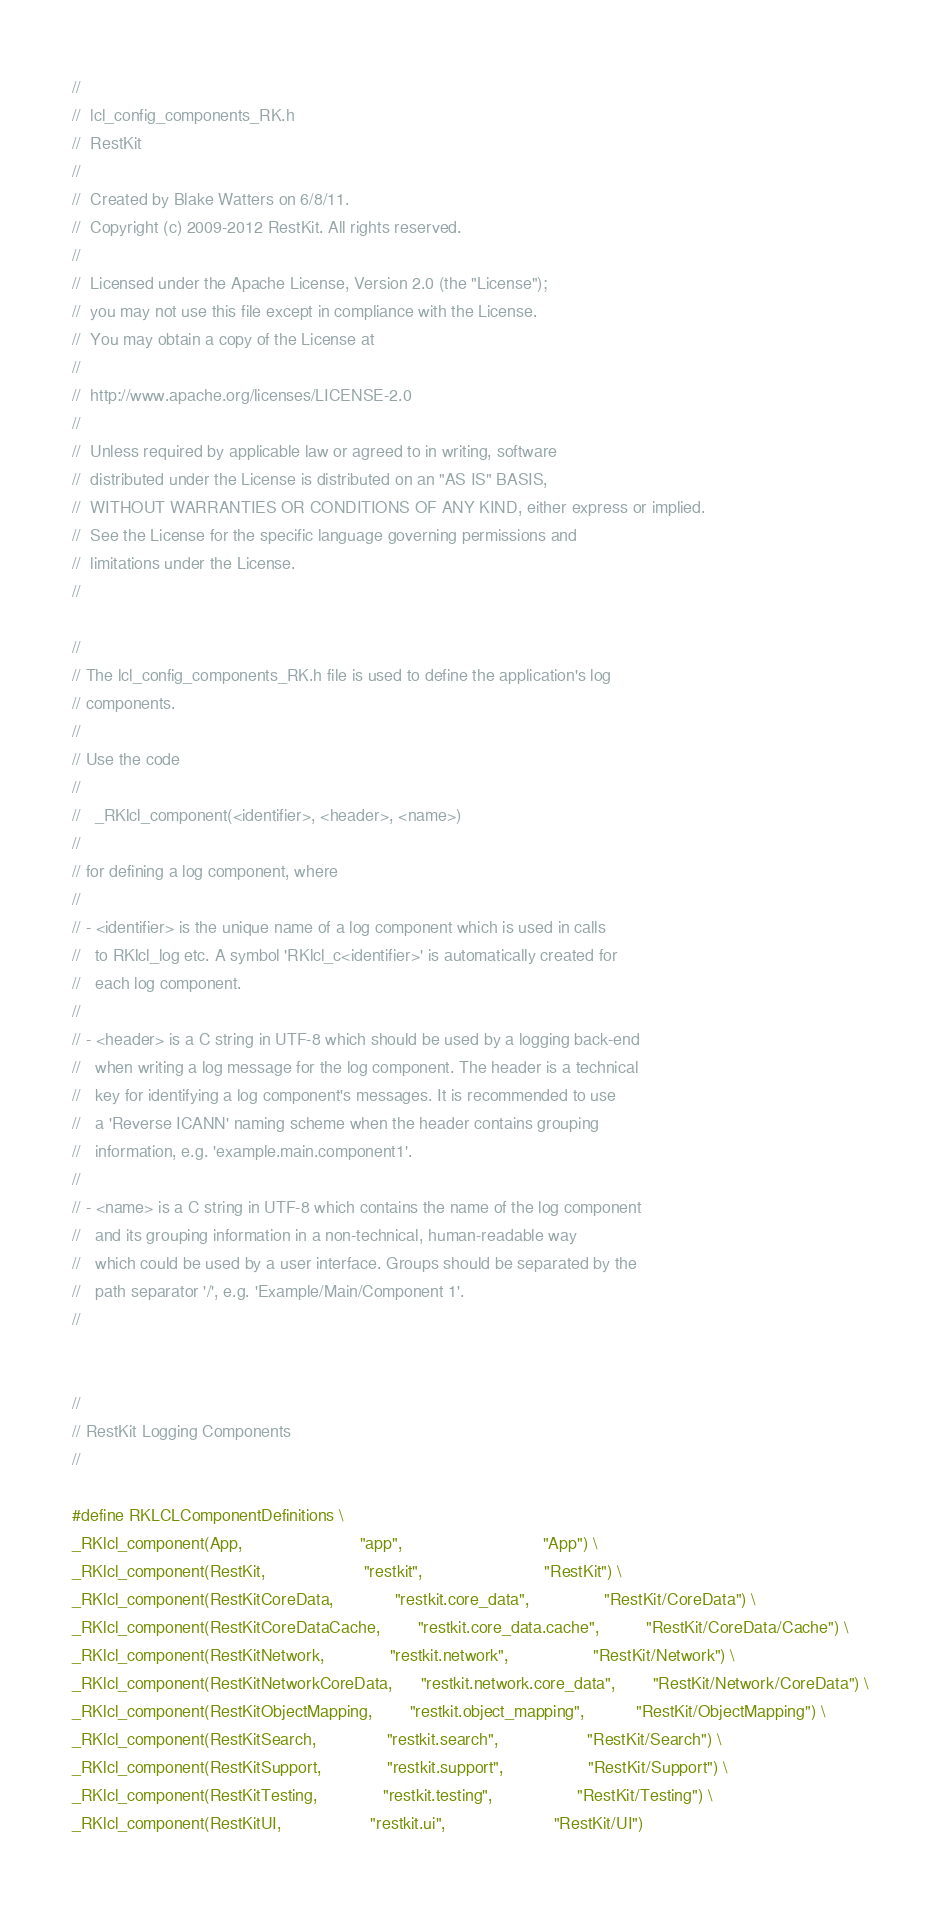Convert code to text. <code><loc_0><loc_0><loc_500><loc_500><_C_>//
//  lcl_config_components_RK.h
//  RestKit
//
//  Created by Blake Watters on 6/8/11.
//  Copyright (c) 2009-2012 RestKit. All rights reserved.
//
//  Licensed under the Apache License, Version 2.0 (the "License");
//  you may not use this file except in compliance with the License.
//  You may obtain a copy of the License at
//
//  http://www.apache.org/licenses/LICENSE-2.0
//
//  Unless required by applicable law or agreed to in writing, software
//  distributed under the License is distributed on an "AS IS" BASIS,
//  WITHOUT WARRANTIES OR CONDITIONS OF ANY KIND, either express or implied.
//  See the License for the specific language governing permissions and
//  limitations under the License.
//

//
// The lcl_config_components_RK.h file is used to define the application's log
// components.
//
// Use the code
//
//   _RKlcl_component(<identifier>, <header>, <name>)
//
// for defining a log component, where
//
// - <identifier> is the unique name of a log component which is used in calls
//   to RKlcl_log etc. A symbol 'RKlcl_c<identifier>' is automatically created for
//   each log component.
//
// - <header> is a C string in UTF-8 which should be used by a logging back-end
//   when writing a log message for the log component. The header is a technical
//   key for identifying a log component's messages. It is recommended to use
//   a 'Reverse ICANN' naming scheme when the header contains grouping
//   information, e.g. 'example.main.component1'.
//
// - <name> is a C string in UTF-8 which contains the name of the log component
//   and its grouping information in a non-technical, human-readable way
//   which could be used by a user interface. Groups should be separated by the
//   path separator '/', e.g. 'Example/Main/Component 1'.
//


//
// RestKit Logging Components
//

#define RKLCLComponentDefinitions \
_RKlcl_component(App,                         "app",                              "App") \
_RKlcl_component(RestKit,                     "restkit",                          "RestKit") \
_RKlcl_component(RestKitCoreData,             "restkit.core_data",                "RestKit/CoreData") \
_RKlcl_component(RestKitCoreDataCache,        "restkit.core_data.cache",          "RestKit/CoreData/Cache") \
_RKlcl_component(RestKitNetwork,              "restkit.network",                  "RestKit/Network") \
_RKlcl_component(RestKitNetworkCoreData,      "restkit.network.core_data",        "RestKit/Network/CoreData") \
_RKlcl_component(RestKitObjectMapping,        "restkit.object_mapping",           "RestKit/ObjectMapping") \
_RKlcl_component(RestKitSearch,               "restkit.search",                   "RestKit/Search") \
_RKlcl_component(RestKitSupport,              "restkit.support",                  "RestKit/Support") \
_RKlcl_component(RestKitTesting,              "restkit.testing",                  "RestKit/Testing") \
_RKlcl_component(RestKitUI,                   "restkit.ui",                       "RestKit/UI")
</code> 